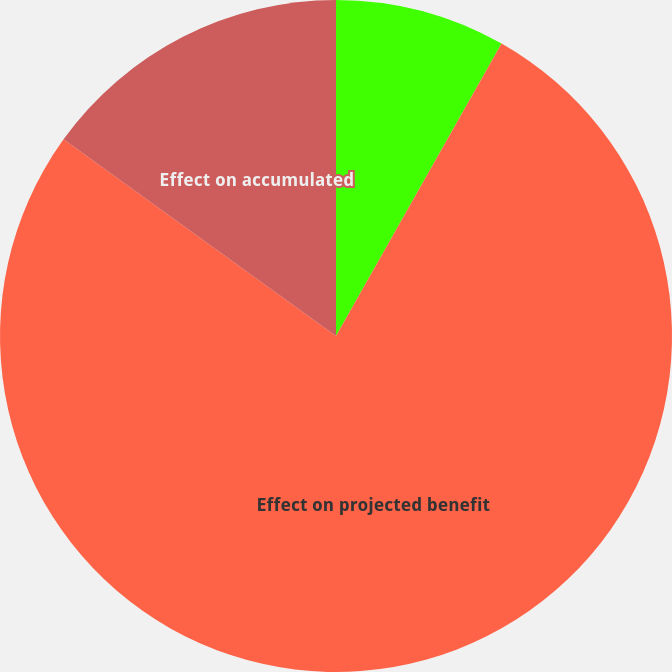Convert chart. <chart><loc_0><loc_0><loc_500><loc_500><pie_chart><fcel>Effect on net periodic benefit<fcel>Effect on projected benefit<fcel>Effect on accumulated<nl><fcel>8.2%<fcel>76.75%<fcel>15.05%<nl></chart> 